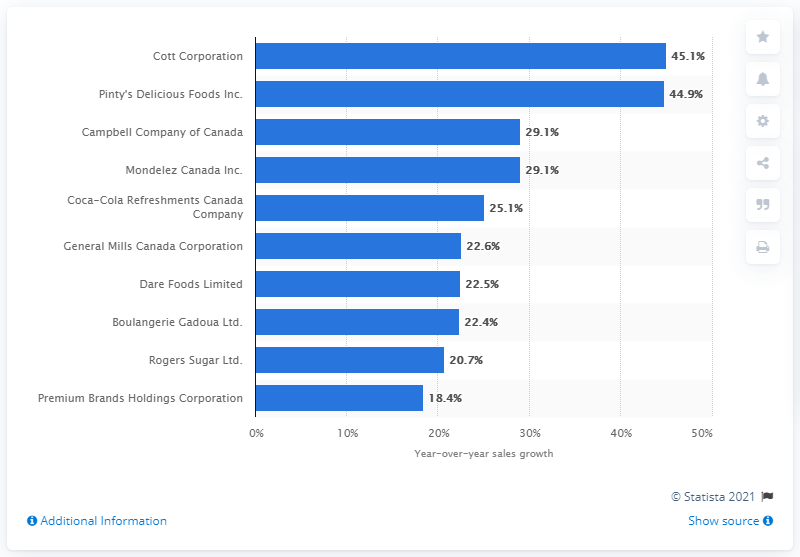Which company had the least sales growth in 2017 according to the chart? Based on the chart, Premium Brands Holdings Corporation had the least sales growth in 2017, with an increase of 18.4%. 